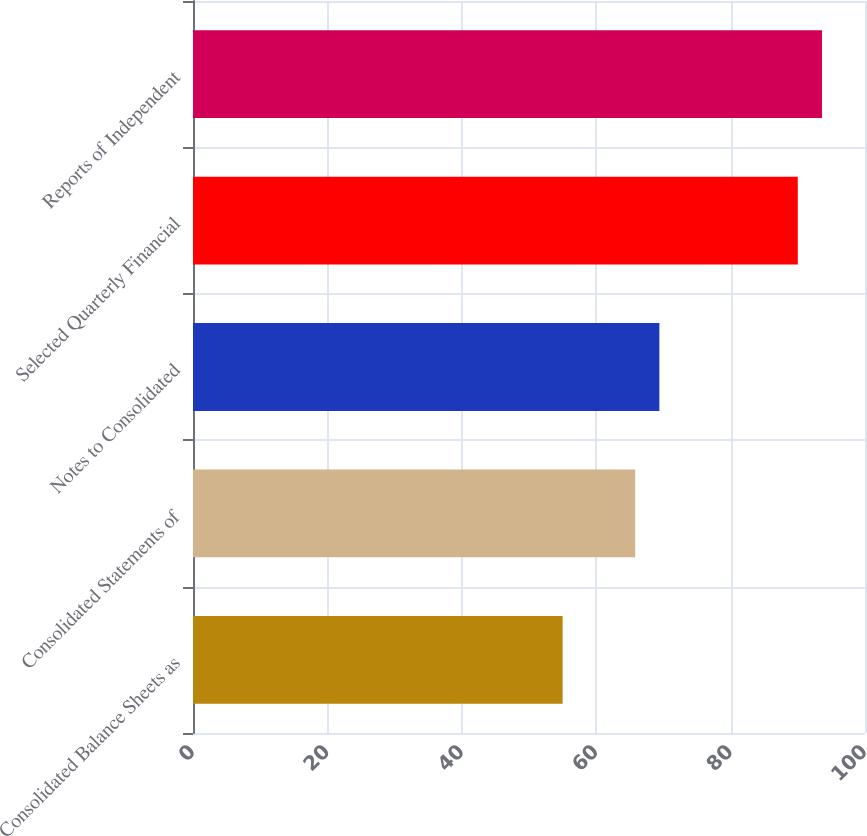Convert chart. <chart><loc_0><loc_0><loc_500><loc_500><bar_chart><fcel>Consolidated Balance Sheets as<fcel>Consolidated Statements of<fcel>Notes to Consolidated<fcel>Selected Quarterly Financial<fcel>Reports of Independent<nl><fcel>55<fcel>65.8<fcel>69.4<fcel>90<fcel>93.6<nl></chart> 